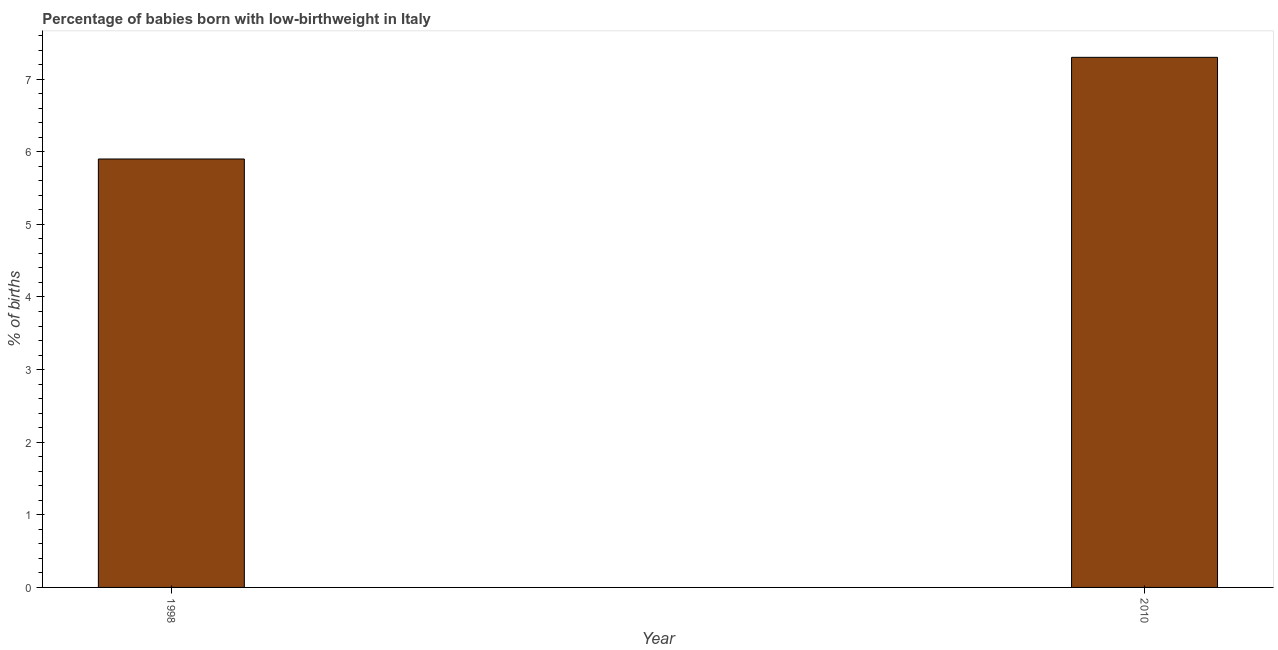What is the title of the graph?
Provide a short and direct response. Percentage of babies born with low-birthweight in Italy. What is the label or title of the X-axis?
Ensure brevity in your answer.  Year. What is the label or title of the Y-axis?
Give a very brief answer. % of births. What is the percentage of babies who were born with low-birthweight in 1998?
Offer a very short reply. 5.9. Across all years, what is the minimum percentage of babies who were born with low-birthweight?
Your answer should be very brief. 5.9. In which year was the percentage of babies who were born with low-birthweight minimum?
Your answer should be very brief. 1998. What is the sum of the percentage of babies who were born with low-birthweight?
Your response must be concise. 13.2. What is the difference between the percentage of babies who were born with low-birthweight in 1998 and 2010?
Offer a terse response. -1.4. In how many years, is the percentage of babies who were born with low-birthweight greater than 4.2 %?
Your answer should be compact. 2. Do a majority of the years between 1998 and 2010 (inclusive) have percentage of babies who were born with low-birthweight greater than 5 %?
Provide a succinct answer. Yes. What is the ratio of the percentage of babies who were born with low-birthweight in 1998 to that in 2010?
Give a very brief answer. 0.81. Is the percentage of babies who were born with low-birthweight in 1998 less than that in 2010?
Your answer should be very brief. Yes. In how many years, is the percentage of babies who were born with low-birthweight greater than the average percentage of babies who were born with low-birthweight taken over all years?
Offer a very short reply. 1. How many years are there in the graph?
Provide a short and direct response. 2. What is the % of births in 1998?
Give a very brief answer. 5.9. What is the % of births of 2010?
Your answer should be very brief. 7.3. What is the difference between the % of births in 1998 and 2010?
Your answer should be very brief. -1.4. What is the ratio of the % of births in 1998 to that in 2010?
Give a very brief answer. 0.81. 